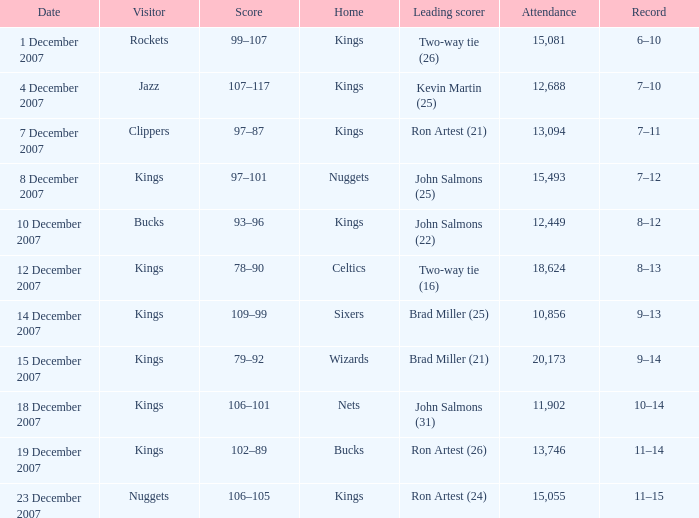When the rockets were the visiting team, what was the game's score? 6–10. 